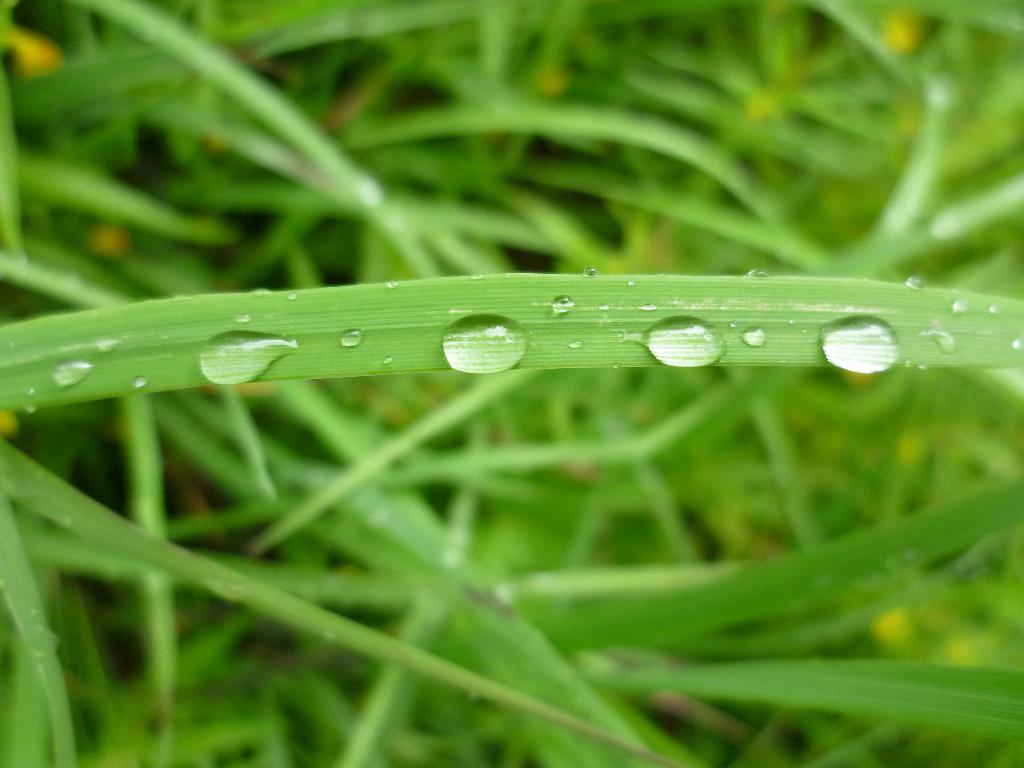Please provide a concise description of this image. In this image we can see water drops on a leaf. In the background the image is blur but we can see plants. 